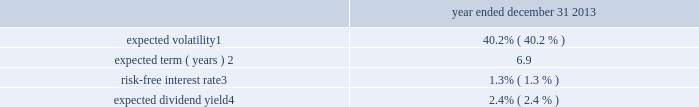Notes to consolidated financial statements 2013 ( continued ) ( amounts in millions , except per share amounts ) assumptions can materially affect the estimate of fair value , and our results of operations could be materially impacted .
There were no stock options granted during the years ended december 31 , 2015 and 2014 .
The weighted-average grant-date fair value per option during the year ended december 31 , 2013 was $ 4.14 .
The fair value of each option grant has been estimated with the following weighted-average assumptions. .
Expected volatility 1 .
40.2% ( 40.2 % ) expected term ( years ) 2 .
6.9 risk-free interest rate 3 .
1.3% ( 1.3 % ) expected dividend yield 4 .
2.4% ( 2.4 % ) 1 the expected volatility used to estimate the fair value of stock options awarded is based on a blend of : ( i ) historical volatility of our common stock for periods equal to the expected term of our stock options and ( ii ) implied volatility of tradable forward put and call options to purchase and sell shares of our common stock .
2 the estimate of our expected term is based on the average of : ( i ) an assumption that all outstanding options are exercised upon achieving their full vesting date and ( ii ) an assumption that all outstanding options will be exercised at the midpoint between the current date ( i.e. , the date awards have ratably vested through ) and their full contractual term .
In determining the estimate , we considered several factors , including the historical option exercise behavior of our employees and the terms and vesting periods of the options .
3 the risk-free interest rate is determined using the implied yield currently available for zero-coupon u.s .
Government issuers with a remaining term equal to the expected term of the options .
4 the expected dividend yield was calculated based on an annualized dividend of $ 0.30 per share in 2013 .
Stock-based compensation we grant other stock-based compensation awards such as stock-settled awards , cash-settled awards and performance- based awards ( settled in cash or shares ) to certain key employees .
The number of shares or units received by an employee for performance-based awards depends on company performance against specific performance targets and could range from 0% ( 0 % ) to 300% ( 300 % ) of the target amount of shares originally granted .
Incentive awards are subject to certain restrictions and vesting requirements as determined by the compensation committee .
The fair value of the shares on the grant date is amortized over the vesting period , which is generally three years .
Upon completion of the vesting period for cash-settled awards , the grantee is entitled to receive a payment in cash based on the fair market value of the corresponding number of shares of common stock .
No monetary consideration is paid by a recipient for any incentive award .
The fair value of cash-settled awards is adjusted each quarter based on our share price .
The holders of stock-settled awards have absolute ownership interest in the underlying shares of common stock prior to vesting , which includes the right to vote and receive dividends .
Dividends declared on common stock are accrued during the vesting period and paid when the award vests .
The holders of cash-settled and performance-based awards have no ownership interest in the underlying shares of common stock until the awards vest and the shares of common stock are issued. .
What is the stock price based on the dividend yield at the time that dividends were declared? 
Computations: (0.30 / 2.4%)
Answer: 12.5. 